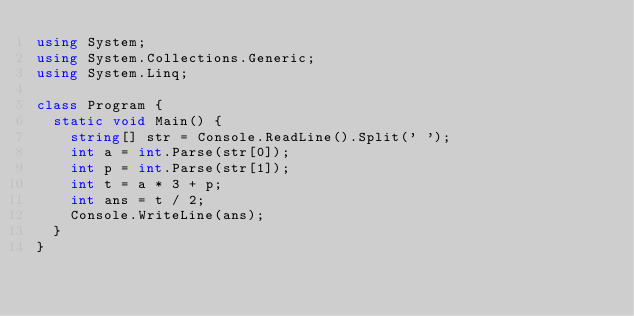<code> <loc_0><loc_0><loc_500><loc_500><_C#_>using System;
using System.Collections.Generic;
using System.Linq;

class Program {
  static void Main() {
    string[] str = Console.ReadLine().Split(' ');
    int a = int.Parse(str[0]);
    int p = int.Parse(str[1]);
    int t = a * 3 + p;
    int ans = t / 2;
    Console.WriteLine(ans);
  }
}</code> 